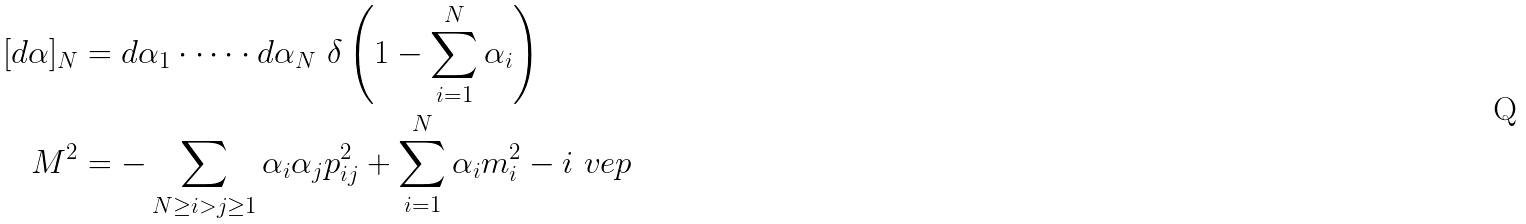Convert formula to latex. <formula><loc_0><loc_0><loc_500><loc_500>[ d \alpha ] _ { N } & = d \alpha _ { 1 } \cdot \dots \cdot d \alpha _ { N } \ \delta \left ( 1 - \sum _ { i = 1 } ^ { N } \alpha _ { i } \right ) \\ M ^ { 2 } & = - \sum _ { N \geq i > j \geq 1 } \alpha _ { i } \alpha _ { j } p _ { i j } ^ { 2 } + \sum _ { i = 1 } ^ { N } \alpha _ { i } m _ { i } ^ { 2 } - i \ v e p</formula> 